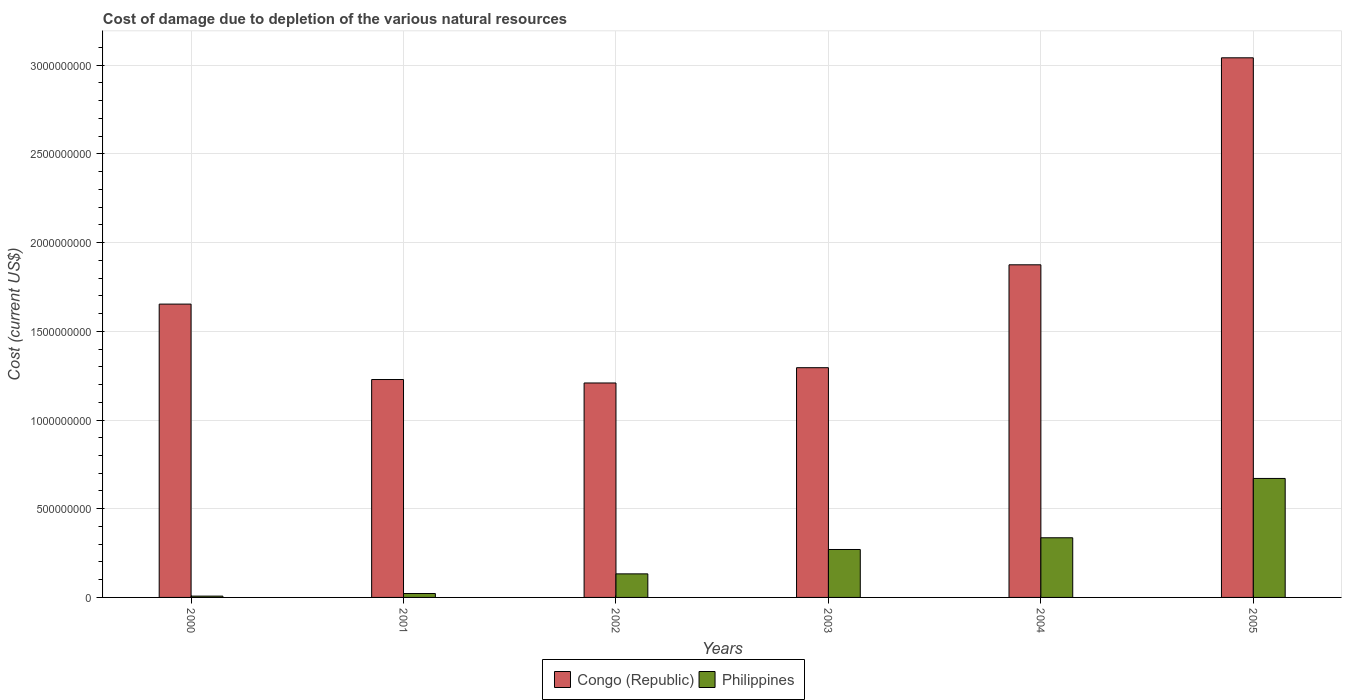How many groups of bars are there?
Ensure brevity in your answer.  6. Are the number of bars per tick equal to the number of legend labels?
Your response must be concise. Yes. Are the number of bars on each tick of the X-axis equal?
Provide a short and direct response. Yes. How many bars are there on the 3rd tick from the right?
Make the answer very short. 2. In how many cases, is the number of bars for a given year not equal to the number of legend labels?
Ensure brevity in your answer.  0. What is the cost of damage caused due to the depletion of various natural resources in Congo (Republic) in 2002?
Provide a succinct answer. 1.21e+09. Across all years, what is the maximum cost of damage caused due to the depletion of various natural resources in Congo (Republic)?
Your response must be concise. 3.04e+09. Across all years, what is the minimum cost of damage caused due to the depletion of various natural resources in Philippines?
Provide a succinct answer. 7.35e+06. In which year was the cost of damage caused due to the depletion of various natural resources in Congo (Republic) maximum?
Offer a terse response. 2005. What is the total cost of damage caused due to the depletion of various natural resources in Philippines in the graph?
Provide a succinct answer. 1.44e+09. What is the difference between the cost of damage caused due to the depletion of various natural resources in Philippines in 2000 and that in 2002?
Make the answer very short. -1.25e+08. What is the difference between the cost of damage caused due to the depletion of various natural resources in Congo (Republic) in 2005 and the cost of damage caused due to the depletion of various natural resources in Philippines in 2001?
Give a very brief answer. 3.02e+09. What is the average cost of damage caused due to the depletion of various natural resources in Philippines per year?
Provide a succinct answer. 2.40e+08. In the year 2004, what is the difference between the cost of damage caused due to the depletion of various natural resources in Congo (Republic) and cost of damage caused due to the depletion of various natural resources in Philippines?
Keep it short and to the point. 1.54e+09. What is the ratio of the cost of damage caused due to the depletion of various natural resources in Congo (Republic) in 2002 to that in 2004?
Keep it short and to the point. 0.64. Is the cost of damage caused due to the depletion of various natural resources in Philippines in 2001 less than that in 2002?
Ensure brevity in your answer.  Yes. Is the difference between the cost of damage caused due to the depletion of various natural resources in Congo (Republic) in 2000 and 2004 greater than the difference between the cost of damage caused due to the depletion of various natural resources in Philippines in 2000 and 2004?
Provide a succinct answer. Yes. What is the difference between the highest and the second highest cost of damage caused due to the depletion of various natural resources in Congo (Republic)?
Keep it short and to the point. 1.17e+09. What is the difference between the highest and the lowest cost of damage caused due to the depletion of various natural resources in Congo (Republic)?
Your answer should be compact. 1.83e+09. In how many years, is the cost of damage caused due to the depletion of various natural resources in Philippines greater than the average cost of damage caused due to the depletion of various natural resources in Philippines taken over all years?
Offer a very short reply. 3. What does the 1st bar from the right in 2002 represents?
Provide a short and direct response. Philippines. How many bars are there?
Your answer should be very brief. 12. How many years are there in the graph?
Ensure brevity in your answer.  6. Does the graph contain any zero values?
Ensure brevity in your answer.  No. Where does the legend appear in the graph?
Your answer should be very brief. Bottom center. How are the legend labels stacked?
Your answer should be very brief. Horizontal. What is the title of the graph?
Your answer should be compact. Cost of damage due to depletion of the various natural resources. Does "Malawi" appear as one of the legend labels in the graph?
Your answer should be compact. No. What is the label or title of the X-axis?
Keep it short and to the point. Years. What is the label or title of the Y-axis?
Provide a succinct answer. Cost (current US$). What is the Cost (current US$) of Congo (Republic) in 2000?
Keep it short and to the point. 1.65e+09. What is the Cost (current US$) in Philippines in 2000?
Ensure brevity in your answer.  7.35e+06. What is the Cost (current US$) in Congo (Republic) in 2001?
Make the answer very short. 1.23e+09. What is the Cost (current US$) in Philippines in 2001?
Your answer should be compact. 2.20e+07. What is the Cost (current US$) in Congo (Republic) in 2002?
Give a very brief answer. 1.21e+09. What is the Cost (current US$) of Philippines in 2002?
Your response must be concise. 1.33e+08. What is the Cost (current US$) in Congo (Republic) in 2003?
Ensure brevity in your answer.  1.30e+09. What is the Cost (current US$) in Philippines in 2003?
Give a very brief answer. 2.70e+08. What is the Cost (current US$) in Congo (Republic) in 2004?
Make the answer very short. 1.88e+09. What is the Cost (current US$) in Philippines in 2004?
Give a very brief answer. 3.36e+08. What is the Cost (current US$) of Congo (Republic) in 2005?
Keep it short and to the point. 3.04e+09. What is the Cost (current US$) in Philippines in 2005?
Offer a terse response. 6.71e+08. Across all years, what is the maximum Cost (current US$) in Congo (Republic)?
Ensure brevity in your answer.  3.04e+09. Across all years, what is the maximum Cost (current US$) of Philippines?
Provide a succinct answer. 6.71e+08. Across all years, what is the minimum Cost (current US$) of Congo (Republic)?
Your answer should be very brief. 1.21e+09. Across all years, what is the minimum Cost (current US$) in Philippines?
Offer a very short reply. 7.35e+06. What is the total Cost (current US$) in Congo (Republic) in the graph?
Your response must be concise. 1.03e+1. What is the total Cost (current US$) in Philippines in the graph?
Provide a short and direct response. 1.44e+09. What is the difference between the Cost (current US$) in Congo (Republic) in 2000 and that in 2001?
Offer a very short reply. 4.25e+08. What is the difference between the Cost (current US$) of Philippines in 2000 and that in 2001?
Offer a very short reply. -1.46e+07. What is the difference between the Cost (current US$) in Congo (Republic) in 2000 and that in 2002?
Your response must be concise. 4.45e+08. What is the difference between the Cost (current US$) of Philippines in 2000 and that in 2002?
Your response must be concise. -1.25e+08. What is the difference between the Cost (current US$) of Congo (Republic) in 2000 and that in 2003?
Your answer should be compact. 3.58e+08. What is the difference between the Cost (current US$) in Philippines in 2000 and that in 2003?
Give a very brief answer. -2.63e+08. What is the difference between the Cost (current US$) of Congo (Republic) in 2000 and that in 2004?
Provide a short and direct response. -2.21e+08. What is the difference between the Cost (current US$) of Philippines in 2000 and that in 2004?
Offer a very short reply. -3.29e+08. What is the difference between the Cost (current US$) of Congo (Republic) in 2000 and that in 2005?
Your response must be concise. -1.39e+09. What is the difference between the Cost (current US$) of Philippines in 2000 and that in 2005?
Ensure brevity in your answer.  -6.63e+08. What is the difference between the Cost (current US$) of Congo (Republic) in 2001 and that in 2002?
Your answer should be very brief. 1.95e+07. What is the difference between the Cost (current US$) of Philippines in 2001 and that in 2002?
Provide a short and direct response. -1.11e+08. What is the difference between the Cost (current US$) in Congo (Republic) in 2001 and that in 2003?
Offer a very short reply. -6.67e+07. What is the difference between the Cost (current US$) in Philippines in 2001 and that in 2003?
Provide a short and direct response. -2.48e+08. What is the difference between the Cost (current US$) in Congo (Republic) in 2001 and that in 2004?
Ensure brevity in your answer.  -6.47e+08. What is the difference between the Cost (current US$) in Philippines in 2001 and that in 2004?
Your answer should be compact. -3.14e+08. What is the difference between the Cost (current US$) of Congo (Republic) in 2001 and that in 2005?
Make the answer very short. -1.81e+09. What is the difference between the Cost (current US$) of Philippines in 2001 and that in 2005?
Offer a very short reply. -6.49e+08. What is the difference between the Cost (current US$) of Congo (Republic) in 2002 and that in 2003?
Ensure brevity in your answer.  -8.62e+07. What is the difference between the Cost (current US$) of Philippines in 2002 and that in 2003?
Give a very brief answer. -1.37e+08. What is the difference between the Cost (current US$) of Congo (Republic) in 2002 and that in 2004?
Provide a short and direct response. -6.66e+08. What is the difference between the Cost (current US$) of Philippines in 2002 and that in 2004?
Provide a succinct answer. -2.04e+08. What is the difference between the Cost (current US$) of Congo (Republic) in 2002 and that in 2005?
Ensure brevity in your answer.  -1.83e+09. What is the difference between the Cost (current US$) of Philippines in 2002 and that in 2005?
Ensure brevity in your answer.  -5.38e+08. What is the difference between the Cost (current US$) of Congo (Republic) in 2003 and that in 2004?
Provide a short and direct response. -5.80e+08. What is the difference between the Cost (current US$) of Philippines in 2003 and that in 2004?
Your answer should be compact. -6.61e+07. What is the difference between the Cost (current US$) in Congo (Republic) in 2003 and that in 2005?
Ensure brevity in your answer.  -1.75e+09. What is the difference between the Cost (current US$) of Philippines in 2003 and that in 2005?
Make the answer very short. -4.01e+08. What is the difference between the Cost (current US$) in Congo (Republic) in 2004 and that in 2005?
Offer a terse response. -1.17e+09. What is the difference between the Cost (current US$) of Philippines in 2004 and that in 2005?
Provide a succinct answer. -3.34e+08. What is the difference between the Cost (current US$) of Congo (Republic) in 2000 and the Cost (current US$) of Philippines in 2001?
Keep it short and to the point. 1.63e+09. What is the difference between the Cost (current US$) of Congo (Republic) in 2000 and the Cost (current US$) of Philippines in 2002?
Your answer should be compact. 1.52e+09. What is the difference between the Cost (current US$) in Congo (Republic) in 2000 and the Cost (current US$) in Philippines in 2003?
Ensure brevity in your answer.  1.38e+09. What is the difference between the Cost (current US$) in Congo (Republic) in 2000 and the Cost (current US$) in Philippines in 2004?
Keep it short and to the point. 1.32e+09. What is the difference between the Cost (current US$) of Congo (Republic) in 2000 and the Cost (current US$) of Philippines in 2005?
Provide a succinct answer. 9.83e+08. What is the difference between the Cost (current US$) of Congo (Republic) in 2001 and the Cost (current US$) of Philippines in 2002?
Ensure brevity in your answer.  1.10e+09. What is the difference between the Cost (current US$) of Congo (Republic) in 2001 and the Cost (current US$) of Philippines in 2003?
Provide a short and direct response. 9.58e+08. What is the difference between the Cost (current US$) of Congo (Republic) in 2001 and the Cost (current US$) of Philippines in 2004?
Keep it short and to the point. 8.92e+08. What is the difference between the Cost (current US$) in Congo (Republic) in 2001 and the Cost (current US$) in Philippines in 2005?
Provide a succinct answer. 5.58e+08. What is the difference between the Cost (current US$) of Congo (Republic) in 2002 and the Cost (current US$) of Philippines in 2003?
Your answer should be compact. 9.39e+08. What is the difference between the Cost (current US$) of Congo (Republic) in 2002 and the Cost (current US$) of Philippines in 2004?
Your answer should be compact. 8.73e+08. What is the difference between the Cost (current US$) of Congo (Republic) in 2002 and the Cost (current US$) of Philippines in 2005?
Offer a terse response. 5.38e+08. What is the difference between the Cost (current US$) of Congo (Republic) in 2003 and the Cost (current US$) of Philippines in 2004?
Provide a short and direct response. 9.59e+08. What is the difference between the Cost (current US$) of Congo (Republic) in 2003 and the Cost (current US$) of Philippines in 2005?
Your response must be concise. 6.24e+08. What is the difference between the Cost (current US$) in Congo (Republic) in 2004 and the Cost (current US$) in Philippines in 2005?
Your answer should be very brief. 1.20e+09. What is the average Cost (current US$) of Congo (Republic) per year?
Offer a terse response. 1.72e+09. What is the average Cost (current US$) in Philippines per year?
Your answer should be very brief. 2.40e+08. In the year 2000, what is the difference between the Cost (current US$) in Congo (Republic) and Cost (current US$) in Philippines?
Offer a very short reply. 1.65e+09. In the year 2001, what is the difference between the Cost (current US$) in Congo (Republic) and Cost (current US$) in Philippines?
Make the answer very short. 1.21e+09. In the year 2002, what is the difference between the Cost (current US$) in Congo (Republic) and Cost (current US$) in Philippines?
Your answer should be compact. 1.08e+09. In the year 2003, what is the difference between the Cost (current US$) of Congo (Republic) and Cost (current US$) of Philippines?
Your response must be concise. 1.02e+09. In the year 2004, what is the difference between the Cost (current US$) in Congo (Republic) and Cost (current US$) in Philippines?
Your answer should be compact. 1.54e+09. In the year 2005, what is the difference between the Cost (current US$) of Congo (Republic) and Cost (current US$) of Philippines?
Provide a short and direct response. 2.37e+09. What is the ratio of the Cost (current US$) in Congo (Republic) in 2000 to that in 2001?
Make the answer very short. 1.35. What is the ratio of the Cost (current US$) of Philippines in 2000 to that in 2001?
Your response must be concise. 0.33. What is the ratio of the Cost (current US$) of Congo (Republic) in 2000 to that in 2002?
Keep it short and to the point. 1.37. What is the ratio of the Cost (current US$) of Philippines in 2000 to that in 2002?
Ensure brevity in your answer.  0.06. What is the ratio of the Cost (current US$) in Congo (Republic) in 2000 to that in 2003?
Keep it short and to the point. 1.28. What is the ratio of the Cost (current US$) in Philippines in 2000 to that in 2003?
Your response must be concise. 0.03. What is the ratio of the Cost (current US$) in Congo (Republic) in 2000 to that in 2004?
Provide a short and direct response. 0.88. What is the ratio of the Cost (current US$) of Philippines in 2000 to that in 2004?
Offer a terse response. 0.02. What is the ratio of the Cost (current US$) in Congo (Republic) in 2000 to that in 2005?
Offer a very short reply. 0.54. What is the ratio of the Cost (current US$) in Philippines in 2000 to that in 2005?
Your answer should be compact. 0.01. What is the ratio of the Cost (current US$) in Congo (Republic) in 2001 to that in 2002?
Your response must be concise. 1.02. What is the ratio of the Cost (current US$) of Philippines in 2001 to that in 2002?
Offer a very short reply. 0.17. What is the ratio of the Cost (current US$) in Congo (Republic) in 2001 to that in 2003?
Your answer should be compact. 0.95. What is the ratio of the Cost (current US$) in Philippines in 2001 to that in 2003?
Provide a succinct answer. 0.08. What is the ratio of the Cost (current US$) in Congo (Republic) in 2001 to that in 2004?
Give a very brief answer. 0.66. What is the ratio of the Cost (current US$) of Philippines in 2001 to that in 2004?
Offer a terse response. 0.07. What is the ratio of the Cost (current US$) of Congo (Republic) in 2001 to that in 2005?
Provide a succinct answer. 0.4. What is the ratio of the Cost (current US$) in Philippines in 2001 to that in 2005?
Your answer should be compact. 0.03. What is the ratio of the Cost (current US$) of Congo (Republic) in 2002 to that in 2003?
Provide a short and direct response. 0.93. What is the ratio of the Cost (current US$) of Philippines in 2002 to that in 2003?
Ensure brevity in your answer.  0.49. What is the ratio of the Cost (current US$) of Congo (Republic) in 2002 to that in 2004?
Your response must be concise. 0.64. What is the ratio of the Cost (current US$) of Philippines in 2002 to that in 2004?
Offer a terse response. 0.39. What is the ratio of the Cost (current US$) in Congo (Republic) in 2002 to that in 2005?
Ensure brevity in your answer.  0.4. What is the ratio of the Cost (current US$) of Philippines in 2002 to that in 2005?
Your response must be concise. 0.2. What is the ratio of the Cost (current US$) in Congo (Republic) in 2003 to that in 2004?
Make the answer very short. 0.69. What is the ratio of the Cost (current US$) of Philippines in 2003 to that in 2004?
Offer a terse response. 0.8. What is the ratio of the Cost (current US$) in Congo (Republic) in 2003 to that in 2005?
Your response must be concise. 0.43. What is the ratio of the Cost (current US$) in Philippines in 2003 to that in 2005?
Ensure brevity in your answer.  0.4. What is the ratio of the Cost (current US$) in Congo (Republic) in 2004 to that in 2005?
Your answer should be very brief. 0.62. What is the ratio of the Cost (current US$) in Philippines in 2004 to that in 2005?
Offer a very short reply. 0.5. What is the difference between the highest and the second highest Cost (current US$) in Congo (Republic)?
Offer a terse response. 1.17e+09. What is the difference between the highest and the second highest Cost (current US$) in Philippines?
Your answer should be compact. 3.34e+08. What is the difference between the highest and the lowest Cost (current US$) of Congo (Republic)?
Your answer should be compact. 1.83e+09. What is the difference between the highest and the lowest Cost (current US$) of Philippines?
Make the answer very short. 6.63e+08. 